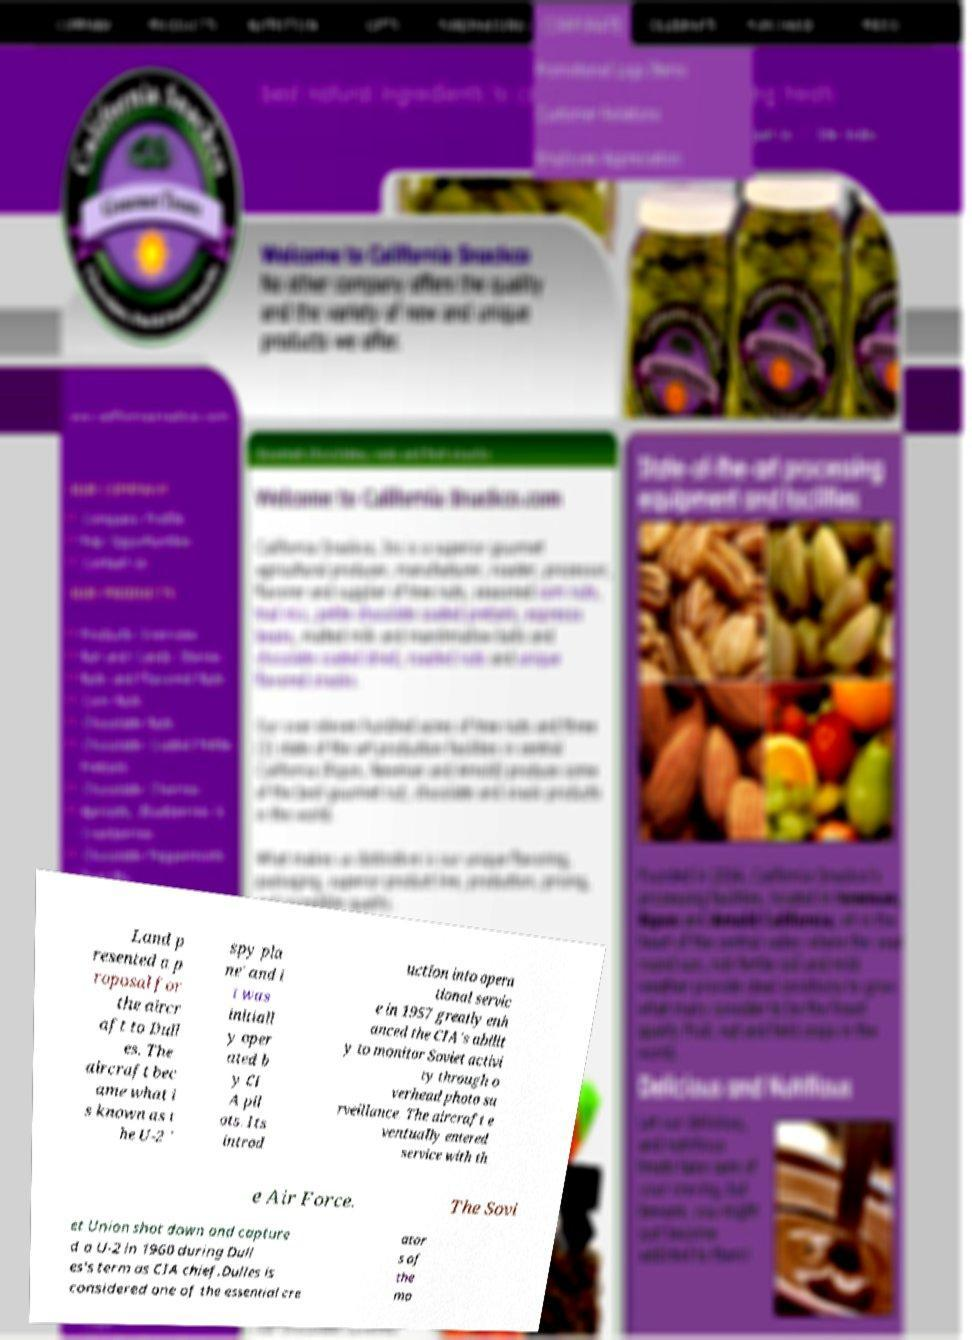Please read and relay the text visible in this image. What does it say? Land p resented a p roposal for the aircr aft to Dull es. The aircraft bec ame what i s known as t he U-2 ' spy pla ne' and i t was initiall y oper ated b y CI A pil ots. Its introd uction into opera tional servic e in 1957 greatly enh anced the CIA's abilit y to monitor Soviet activi ty through o verhead photo su rveillance. The aircraft e ventually entered service with th e Air Force. The Sovi et Union shot down and capture d a U-2 in 1960 during Dull es's term as CIA chief.Dulles is considered one of the essential cre ator s of the mo 